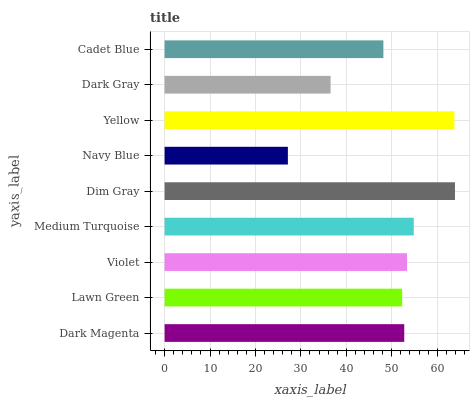Is Navy Blue the minimum?
Answer yes or no. Yes. Is Dim Gray the maximum?
Answer yes or no. Yes. Is Lawn Green the minimum?
Answer yes or no. No. Is Lawn Green the maximum?
Answer yes or no. No. Is Dark Magenta greater than Lawn Green?
Answer yes or no. Yes. Is Lawn Green less than Dark Magenta?
Answer yes or no. Yes. Is Lawn Green greater than Dark Magenta?
Answer yes or no. No. Is Dark Magenta less than Lawn Green?
Answer yes or no. No. Is Dark Magenta the high median?
Answer yes or no. Yes. Is Dark Magenta the low median?
Answer yes or no. Yes. Is Yellow the high median?
Answer yes or no. No. Is Dim Gray the low median?
Answer yes or no. No. 